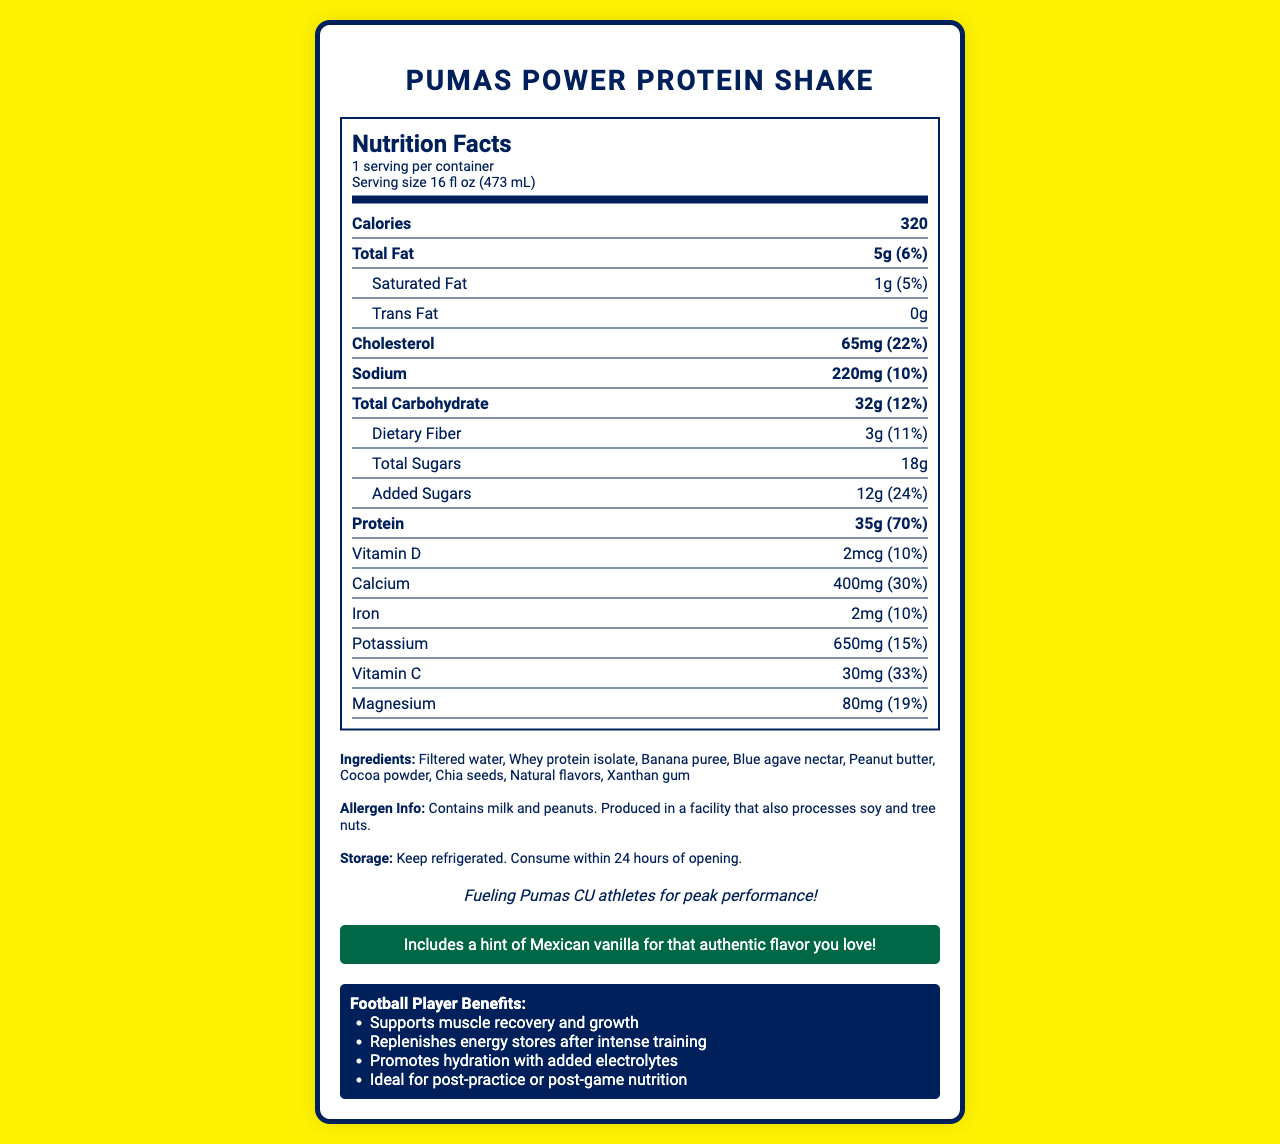what is the serving size of the Pumas Power Protein Shake? The serving size is listed at the top of the Nutrition Facts label.
Answer: 16 fl oz (473 mL) how many calories are in one serving? The calories content is clearly stated under the main nutrients section in the Nutrition Facts label.
Answer: 320 calories what percentage of the daily value for protein does one serving provide? This information is found in the main nutrients section, where "Protein" is listed with a daily value percentage.
Answer: 70% what are the ingredients in this protein shake? The ingredients are listed towards the bottom of the label in the ingredients section.
Answer: Filtered water, Whey protein isolate, Banana puree, Blue agave nectar, Peanut butter, Cocoa powder, Chia seeds, Natural flavors, Xanthan gum what vitamins and minerals are included in this shake? The vitamins and minerals are listed under the nutrient section of the label.
Answer: Vitamin D, Calcium, Iron, Potassium, Vitamin C, Magnesium which of the following is NOT an ingredient in the protein shake? A. Whey protein isolate B. Cocoa powder C. Corn syrup D. Chia seeds Corn syrup is not listed among the ingredients in the document.
Answer: C. Corn syrup what is the primary allergen information provided? The allergen information is provided at the bottom of the document under the allergen info section.
Answer: Contains milk and peanuts. how much dietary fiber does this shake contain per serving? This information is found under the Total Carbohydrate section in the Nutrition Facts label.
Answer: 3g what storage instructions are provided for this shake? The storage instructions are listed underneath the allergen info.
Answer: Keep refrigerated. Consume within 24 hours of opening. does this shake contain any trans fat? The amount of trans fat is listed as 0g in the nutrition label.
Answer: No which nutrient has the highest daily value percentage in this protein shake? A. Protein B. Calcium C. Added Sugars D. Magnesium Protein has a daily value percentage of 70%, which is higher than the other listed nutrients.
Answer: A. Protein is the information about the exact amount of electrolytes in this shake available? The document mentions "Promotes hydration with added electrolytes" but does not specify the exact amount.
Answer: Not enough information can the Pumas Power Protein Shake support energy replenishment after a game? The football benefits section mentions that the shake "Replenishes energy stores after intense training".
Answer: Yes please summarize the main idea of the document. The label provides comprehensive nutritional information and highlights benefits specifically tailored for football players.
Answer: The document is an informative Nutrition Facts label for the "Pumas Power Protein Shake," designed for college football players. It includes details about serving size, caloric content, nutrients, ingredients, allergen information, storage instructions, and benefits for football players, as well as a brand statement emphasizing its purpose to fuel Pumas CU athletes for peak performance. how many grams of total sugars are in one serving of the Pumas Power Protein Shake? This information is listed under the carbohydrates section in the Nutrition Facts label, stating that total sugars are 18g.
Answer: 18g 